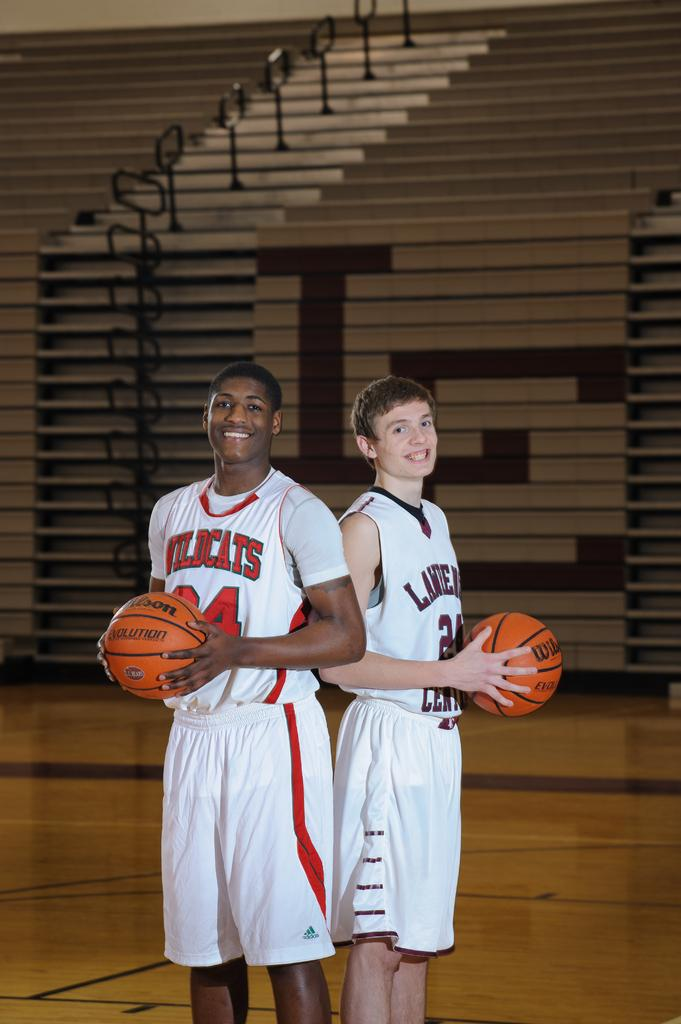<image>
Relay a brief, clear account of the picture shown. Wildcats is the name of the team on the jersey of this basketball player. 